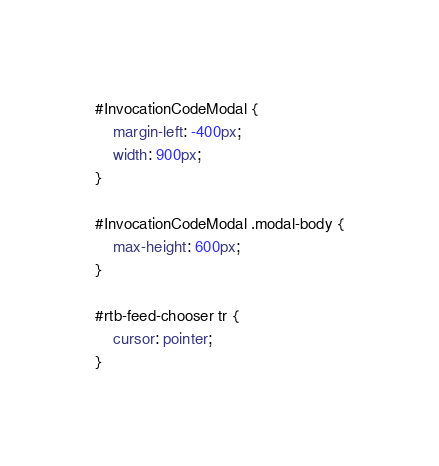Convert code to text. <code><loc_0><loc_0><loc_500><loc_500><_CSS_>#InvocationCodeModal {
    margin-left: -400px;
    width: 900px;
}

#InvocationCodeModal .modal-body {
	max-height: 600px;
}

#rtb-feed-chooser tr {
	cursor: pointer;
}</code> 